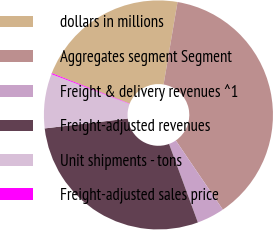Convert chart to OTSL. <chart><loc_0><loc_0><loc_500><loc_500><pie_chart><fcel>dollars in millions<fcel>Aggregates segment Segment<fcel>Freight & delivery revenues ^1<fcel>Freight-adjusted revenues<fcel>Unit shipments - tons<fcel>Freight-adjusted sales price<nl><fcel>21.73%<fcel>37.83%<fcel>3.91%<fcel>28.72%<fcel>7.68%<fcel>0.14%<nl></chart> 